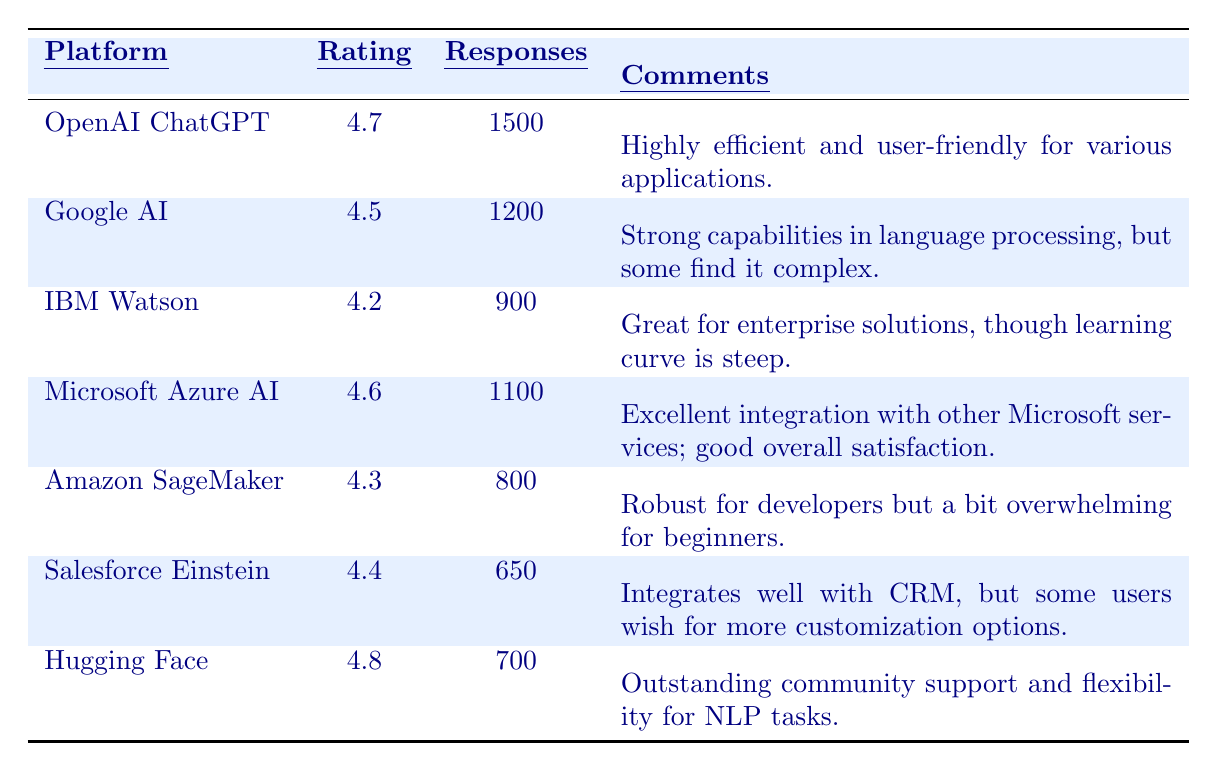What is the highest customer satisfaction rating among the AI platforms? The highest rating is found by comparing all the ratings in the table, which are: 4.7 (OpenAI ChatGPT), 4.5 (Google AI), 4.2 (IBM Watson), 4.6 (Microsoft Azure AI), 4.3 (Amazon SageMaker), 4.4 (Salesforce Einstein), and 4.8 (Hugging Face). The highest value is 4.8 for Hugging Face.
Answer: 4.8 How many total responses were given across all platforms? To find the total number of responses, we sum the number of responses from each platform: 1500 (OpenAI ChatGPT) + 1200 (Google AI) + 900 (IBM Watson) + 1100 (Microsoft Azure AI) + 800 (Amazon SageMaker) + 650 (Salesforce Einstein) + 700 (Hugging Face) = 5850.
Answer: 5850 Which platform received the lowest customer satisfaction rating? The platform with the lowest rating can be identified by looking at all the values; the lowest rating is 4.2 for IBM Watson since all other ratings are higher than this value.
Answer: IBM Watson Is Hugging Face rated higher than Google AI? By comparing the ratings, Hugging Face has a rating of 4.8, while Google AI has a rating of 4.5. Since 4.8 is greater than 4.5, Hugging Face is rated higher.
Answer: Yes What is the average customer satisfaction rating of the AI platforms listed? To calculate the average rating, we sum the ratings: 4.7 + 4.5 + 4.2 + 4.6 + 4.3 + 4.4 + 4.8 = 28.5. Then we divide by the number of platforms (7) to get the average: 28.5 / 7 = 4.07.
Answer: 4.07 How many responses did Hugging Face receive? The number of responses for Hugging Face is listed directly in the table as 700.
Answer: 700 Which platform has a user rating that is closest to the average rating? The average rating is calculated as 4.07. We compare this with each rating: OpenAI ChatGPT (4.7), Google AI (4.5), IBM Watson (4.2), Microsoft Azure AI (4.6), Amazon SageMaker (4.3), Salesforce Einstein (4.4), Hugging Face (4.8). The closest ratings to 4.07 are 4.2 (IBM Watson) and 4.3 (Amazon SageMaker), but 4.3 is closer.
Answer: Amazon SageMaker Does Salesforce Einstein have more responses than Amazon SageMaker? The number of responses for Salesforce Einstein is 650, while Amazon SageMaker has 800 responses. Since 650 is less than 800, Salesforce Einstein does not have more responses.
Answer: No Which platform's ratings and responses indicate it has the highest engagement based on user feedback? Engagement can be interpreted as the product of ratings and the number of responses. For OpenAI ChatGPT: 4.7 * 1500 = 7050; for Google AI: 4.5 * 1200 = 5400; for IBM Watson: 4.2 * 900 = 3780; for Microsoft Azure AI: 4.6 * 1100 = 5060; for Amazon SageMaker: 4.3 * 800 = 3440; for Salesforce Einstein: 4.4 * 650 = 2860; for Hugging Face: 4.8 * 700 = 3360. The highest engagement score is 7050 for OpenAI ChatGPT.
Answer: OpenAI ChatGPT 